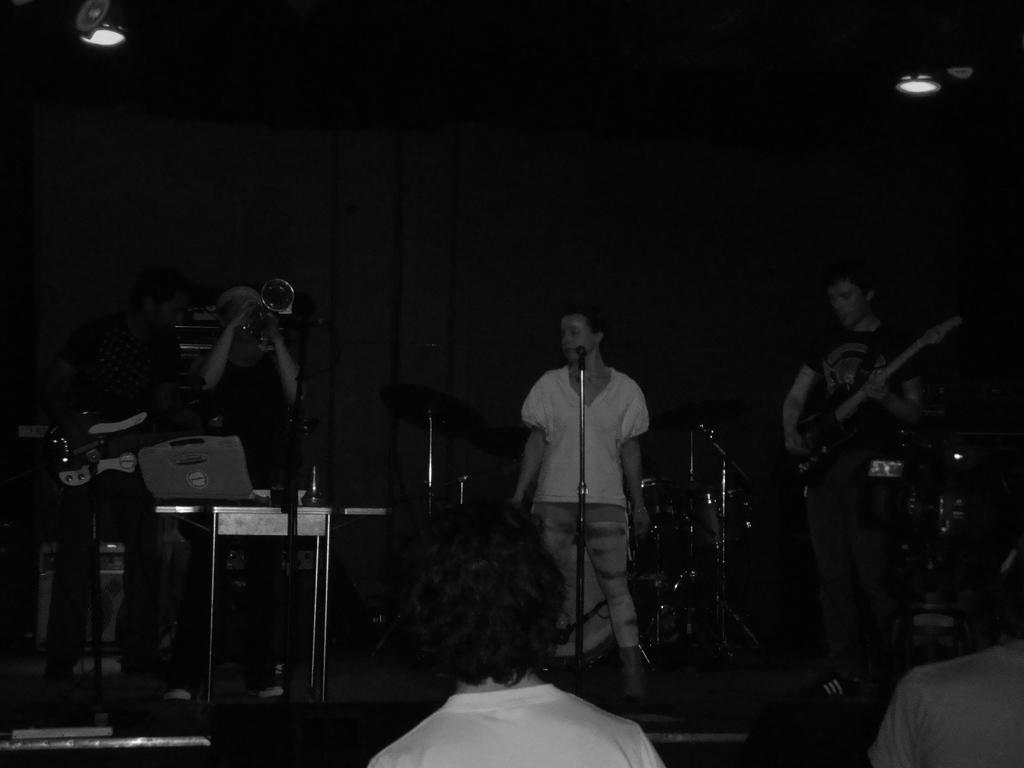What are the persons in the image doing? The persons in the image are playing musical instruments. Can you describe the position of one person in the image? One person is standing in front of a mic. Who is present in the image besides the musicians? There are audience members in front of the musicians. What type of button can be seen on the musician's shirt in the image? There is no button visible on the musician's shirt in the image. How does the audience member in the front row burn the music sheet in the image? There is no indication of a music sheet or anyone burning anything in the image. 